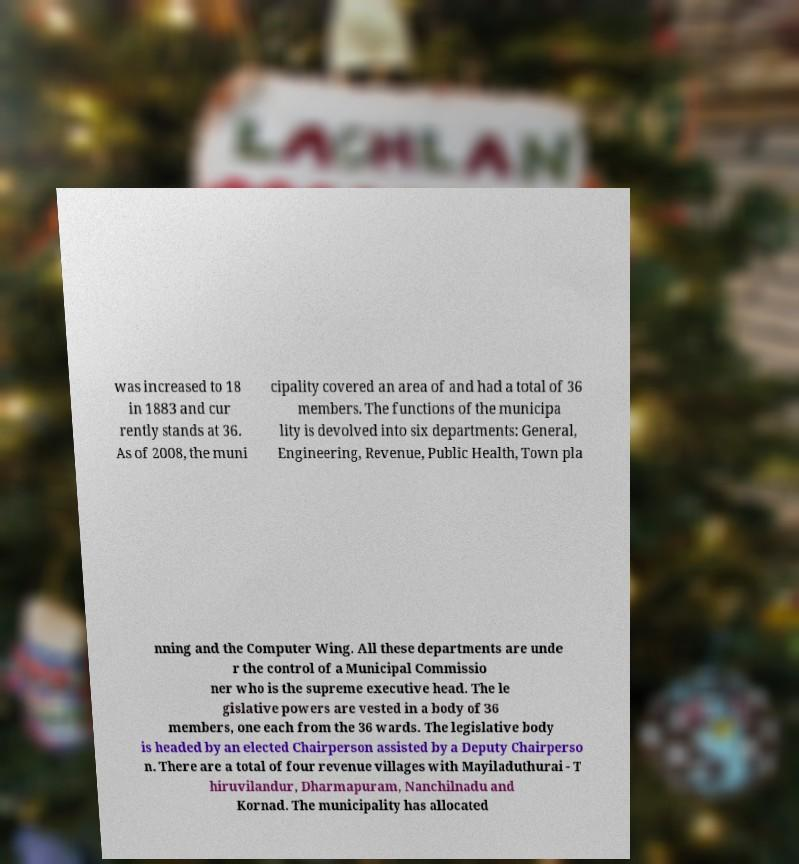For documentation purposes, I need the text within this image transcribed. Could you provide that? was increased to 18 in 1883 and cur rently stands at 36. As of 2008, the muni cipality covered an area of and had a total of 36 members. The functions of the municipa lity is devolved into six departments: General, Engineering, Revenue, Public Health, Town pla nning and the Computer Wing. All these departments are unde r the control of a Municipal Commissio ner who is the supreme executive head. The le gislative powers are vested in a body of 36 members, one each from the 36 wards. The legislative body is headed by an elected Chairperson assisted by a Deputy Chairperso n. There are a total of four revenue villages with Mayiladuthurai - T hiruvilandur, Dharmapuram, Nanchilnadu and Kornad. The municipality has allocated 